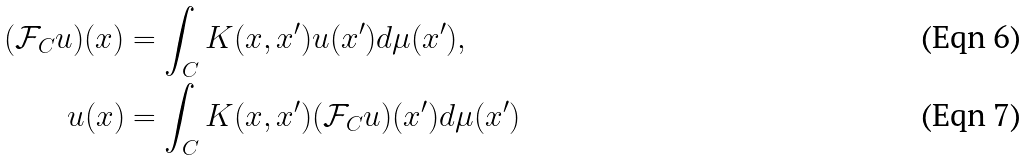Convert formula to latex. <formula><loc_0><loc_0><loc_500><loc_500>( \mathcal { F } _ { C } u ) ( x ) & = \int _ { C } K ( x , x ^ { \prime } ) u ( x ^ { \prime } ) d \mu ( x ^ { \prime } ) , \\ u ( x ) & = \int _ { C } K ( x , x ^ { \prime } ) ( \mathcal { F } _ { C } u ) ( x ^ { \prime } ) d \mu ( x ^ { \prime } )</formula> 